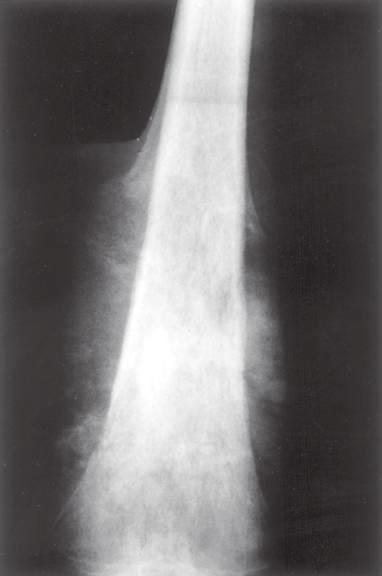what has laid down a triangular shell of reactive bone known as a codman triangle?
Answer the question using a single word or phrase. The periosteum 